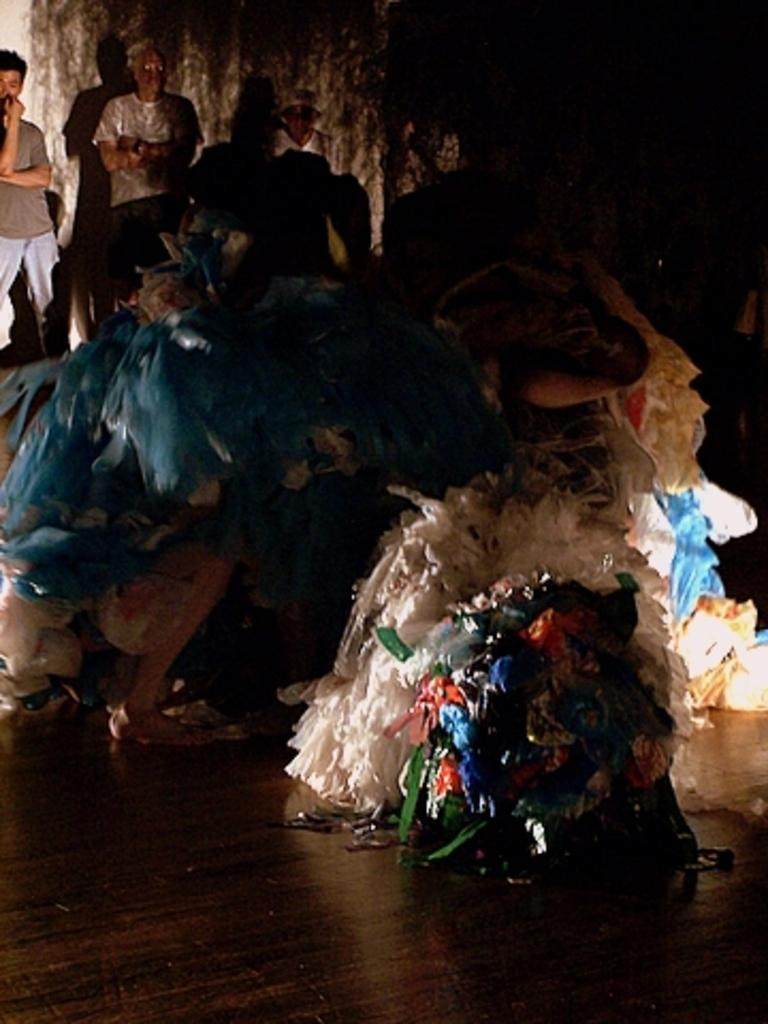What type of objects are present on the floor in the image? There are plastic covers on the floor in the image. What can be seen in the background of the image? There are people and a wall visible in the background of the image. What type of crate is being used to store the bomb in the image? There is no crate or bomb present in the image. 